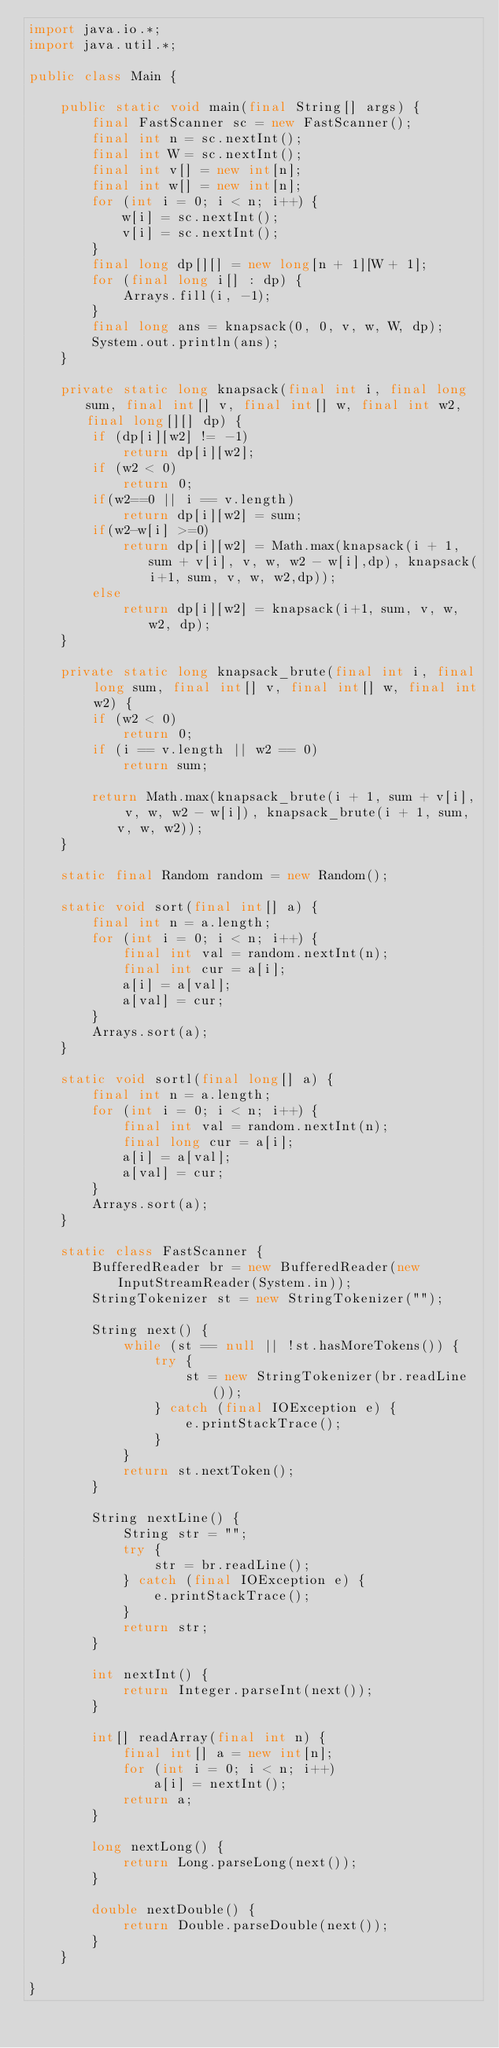<code> <loc_0><loc_0><loc_500><loc_500><_Java_>import java.io.*;
import java.util.*;

public class Main {

    public static void main(final String[] args) {
        final FastScanner sc = new FastScanner();
        final int n = sc.nextInt();
        final int W = sc.nextInt();
        final int v[] = new int[n];
        final int w[] = new int[n];
        for (int i = 0; i < n; i++) {
            w[i] = sc.nextInt();
            v[i] = sc.nextInt();
        }
        final long dp[][] = new long[n + 1][W + 1];
        for (final long i[] : dp) {
            Arrays.fill(i, -1);
        }
        final long ans = knapsack(0, 0, v, w, W, dp);
        System.out.println(ans);
    }

    private static long knapsack(final int i, final long sum, final int[] v, final int[] w, final int w2,final long[][] dp) {
        if (dp[i][w2] != -1)
            return dp[i][w2];
        if (w2 < 0)
            return 0;
        if(w2==0 || i == v.length)
            return dp[i][w2] = sum;
        if(w2-w[i] >=0)
            return dp[i][w2] = Math.max(knapsack(i + 1, sum + v[i], v, w, w2 - w[i],dp), knapsack(i+1, sum, v, w, w2,dp));
        else
            return dp[i][w2] = knapsack(i+1, sum, v, w, w2, dp);
    }

    private static long knapsack_brute(final int i, final long sum, final int[] v, final int[] w, final int w2) {
        if (w2 < 0)
            return 0;
        if (i == v.length || w2 == 0)
            return sum;

        return Math.max(knapsack_brute(i + 1, sum + v[i], v, w, w2 - w[i]), knapsack_brute(i + 1, sum, v, w, w2));
    }

    static final Random random = new Random();

    static void sort(final int[] a) {
        final int n = a.length;
        for (int i = 0; i < n; i++) {
            final int val = random.nextInt(n);
            final int cur = a[i];
            a[i] = a[val];
            a[val] = cur;
        }
        Arrays.sort(a);
    }

    static void sortl(final long[] a) {
        final int n = a.length;
        for (int i = 0; i < n; i++) {
            final int val = random.nextInt(n);
            final long cur = a[i];
            a[i] = a[val];
            a[val] = cur;
        }
        Arrays.sort(a);
    }

    static class FastScanner {
        BufferedReader br = new BufferedReader(new InputStreamReader(System.in));
        StringTokenizer st = new StringTokenizer("");

        String next() {
            while (st == null || !st.hasMoreTokens()) {
                try {
                    st = new StringTokenizer(br.readLine());
                } catch (final IOException e) {
                    e.printStackTrace();
                }
            }
            return st.nextToken();
        }

        String nextLine() {
            String str = "";
            try {
                str = br.readLine();
            } catch (final IOException e) {
                e.printStackTrace();
            }
            return str;
        }

        int nextInt() {
            return Integer.parseInt(next());
        }

        int[] readArray(final int n) {
            final int[] a = new int[n];
            for (int i = 0; i < n; i++)
                a[i] = nextInt();
            return a;
        }

        long nextLong() {
            return Long.parseLong(next());
        }

        double nextDouble() {
            return Double.parseDouble(next());
        }
    }

}
</code> 